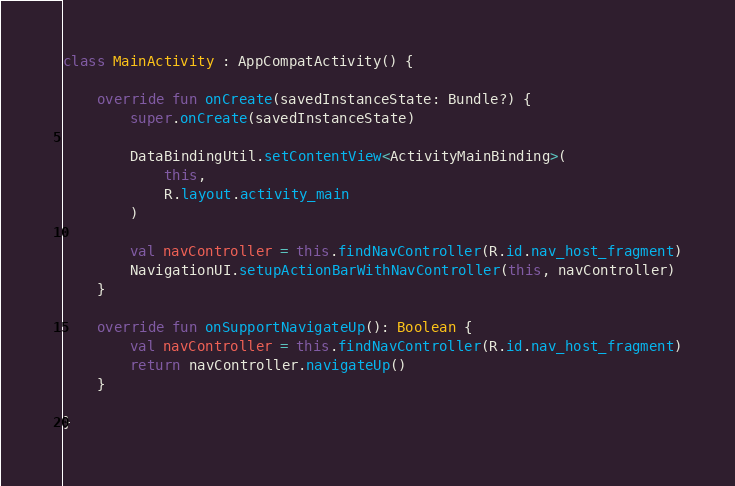<code> <loc_0><loc_0><loc_500><loc_500><_Kotlin_>
class MainActivity : AppCompatActivity() {

    override fun onCreate(savedInstanceState: Bundle?) {
        super.onCreate(savedInstanceState)

        DataBindingUtil.setContentView<ActivityMainBinding>(
            this,
            R.layout.activity_main
        )

        val navController = this.findNavController(R.id.nav_host_fragment)
        NavigationUI.setupActionBarWithNavController(this, navController)
    }

    override fun onSupportNavigateUp(): Boolean {
        val navController = this.findNavController(R.id.nav_host_fragment)
        return navController.navigateUp()
    }

}
</code> 